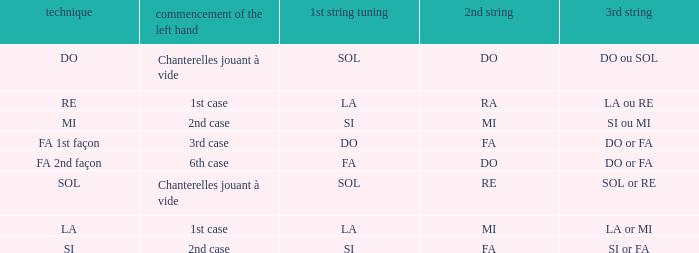For a 1st string of si Accord du and a 2nd string of mi what is the 3rd string? SI ou MI. 